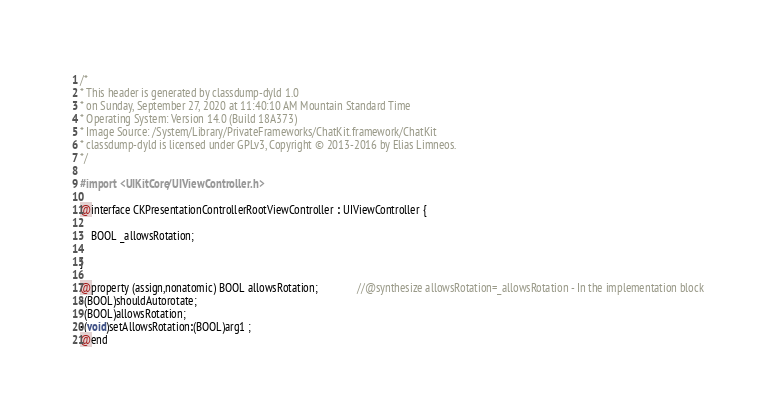Convert code to text. <code><loc_0><loc_0><loc_500><loc_500><_C_>/*
* This header is generated by classdump-dyld 1.0
* on Sunday, September 27, 2020 at 11:40:10 AM Mountain Standard Time
* Operating System: Version 14.0 (Build 18A373)
* Image Source: /System/Library/PrivateFrameworks/ChatKit.framework/ChatKit
* classdump-dyld is licensed under GPLv3, Copyright © 2013-2016 by Elias Limneos.
*/

#import <UIKitCore/UIViewController.h>

@interface CKPresentationControllerRootViewController : UIViewController {

	BOOL _allowsRotation;

}

@property (assign,nonatomic) BOOL allowsRotation;              //@synthesize allowsRotation=_allowsRotation - In the implementation block
-(BOOL)shouldAutorotate;
-(BOOL)allowsRotation;
-(void)setAllowsRotation:(BOOL)arg1 ;
@end

</code> 